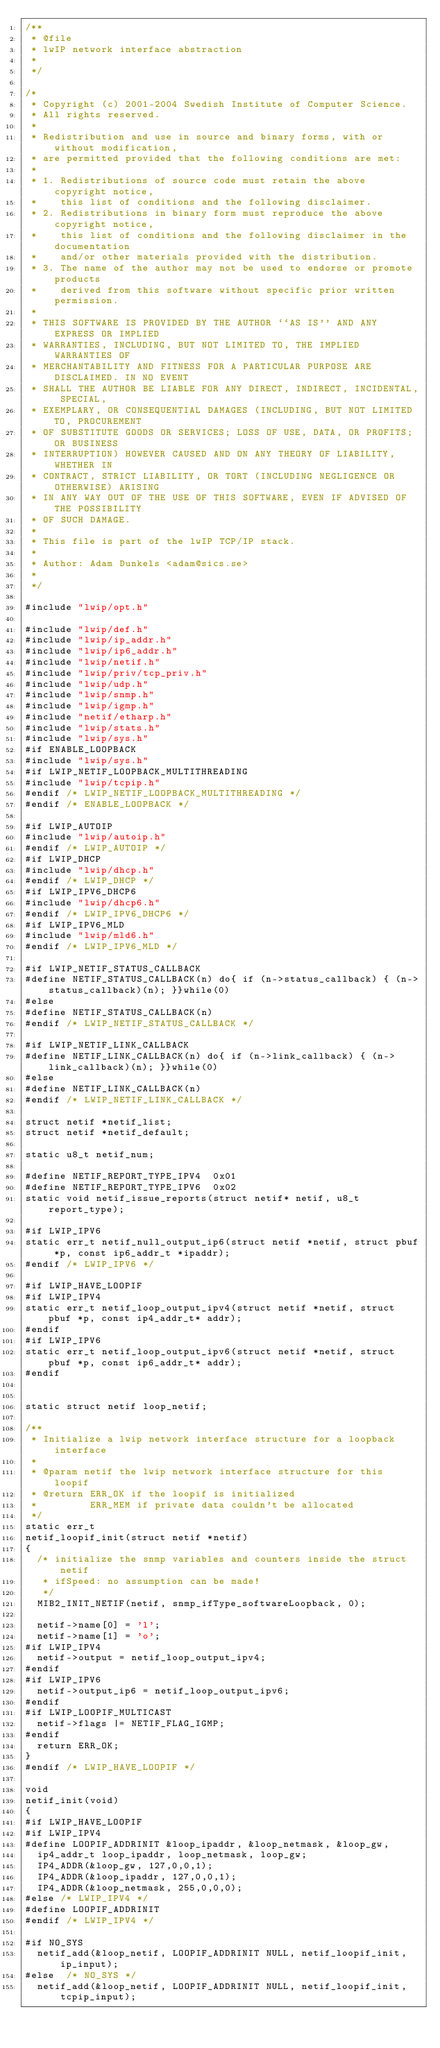<code> <loc_0><loc_0><loc_500><loc_500><_C_>/**
 * @file
 * lwIP network interface abstraction
 *
 */

/*
 * Copyright (c) 2001-2004 Swedish Institute of Computer Science.
 * All rights reserved.
 *
 * Redistribution and use in source and binary forms, with or without modification,
 * are permitted provided that the following conditions are met:
 *
 * 1. Redistributions of source code must retain the above copyright notice,
 *    this list of conditions and the following disclaimer.
 * 2. Redistributions in binary form must reproduce the above copyright notice,
 *    this list of conditions and the following disclaimer in the documentation
 *    and/or other materials provided with the distribution.
 * 3. The name of the author may not be used to endorse or promote products
 *    derived from this software without specific prior written permission.
 *
 * THIS SOFTWARE IS PROVIDED BY THE AUTHOR ``AS IS'' AND ANY EXPRESS OR IMPLIED
 * WARRANTIES, INCLUDING, BUT NOT LIMITED TO, THE IMPLIED WARRANTIES OF
 * MERCHANTABILITY AND FITNESS FOR A PARTICULAR PURPOSE ARE DISCLAIMED. IN NO EVENT
 * SHALL THE AUTHOR BE LIABLE FOR ANY DIRECT, INDIRECT, INCIDENTAL, SPECIAL,
 * EXEMPLARY, OR CONSEQUENTIAL DAMAGES (INCLUDING, BUT NOT LIMITED TO, PROCUREMENT
 * OF SUBSTITUTE GOODS OR SERVICES; LOSS OF USE, DATA, OR PROFITS; OR BUSINESS
 * INTERRUPTION) HOWEVER CAUSED AND ON ANY THEORY OF LIABILITY, WHETHER IN
 * CONTRACT, STRICT LIABILITY, OR TORT (INCLUDING NEGLIGENCE OR OTHERWISE) ARISING
 * IN ANY WAY OUT OF THE USE OF THIS SOFTWARE, EVEN IF ADVISED OF THE POSSIBILITY
 * OF SUCH DAMAGE.
 *
 * This file is part of the lwIP TCP/IP stack.
 *
 * Author: Adam Dunkels <adam@sics.se>
 *
 */

#include "lwip/opt.h"

#include "lwip/def.h"
#include "lwip/ip_addr.h"
#include "lwip/ip6_addr.h"
#include "lwip/netif.h"
#include "lwip/priv/tcp_priv.h"
#include "lwip/udp.h"
#include "lwip/snmp.h"
#include "lwip/igmp.h"
#include "netif/etharp.h"
#include "lwip/stats.h"
#include "lwip/sys.h"
#if ENABLE_LOOPBACK
#include "lwip/sys.h"
#if LWIP_NETIF_LOOPBACK_MULTITHREADING
#include "lwip/tcpip.h"
#endif /* LWIP_NETIF_LOOPBACK_MULTITHREADING */
#endif /* ENABLE_LOOPBACK */

#if LWIP_AUTOIP
#include "lwip/autoip.h"
#endif /* LWIP_AUTOIP */
#if LWIP_DHCP
#include "lwip/dhcp.h"
#endif /* LWIP_DHCP */
#if LWIP_IPV6_DHCP6
#include "lwip/dhcp6.h"
#endif /* LWIP_IPV6_DHCP6 */
#if LWIP_IPV6_MLD
#include "lwip/mld6.h"
#endif /* LWIP_IPV6_MLD */

#if LWIP_NETIF_STATUS_CALLBACK
#define NETIF_STATUS_CALLBACK(n) do{ if (n->status_callback) { (n->status_callback)(n); }}while(0)
#else
#define NETIF_STATUS_CALLBACK(n)
#endif /* LWIP_NETIF_STATUS_CALLBACK */

#if LWIP_NETIF_LINK_CALLBACK
#define NETIF_LINK_CALLBACK(n) do{ if (n->link_callback) { (n->link_callback)(n); }}while(0)
#else
#define NETIF_LINK_CALLBACK(n)
#endif /* LWIP_NETIF_LINK_CALLBACK */

struct netif *netif_list;
struct netif *netif_default;

static u8_t netif_num;

#define NETIF_REPORT_TYPE_IPV4  0x01
#define NETIF_REPORT_TYPE_IPV6  0x02
static void netif_issue_reports(struct netif* netif, u8_t report_type);

#if LWIP_IPV6
static err_t netif_null_output_ip6(struct netif *netif, struct pbuf *p, const ip6_addr_t *ipaddr);
#endif /* LWIP_IPV6 */

#if LWIP_HAVE_LOOPIF
#if LWIP_IPV4
static err_t netif_loop_output_ipv4(struct netif *netif, struct pbuf *p, const ip4_addr_t* addr);
#endif
#if LWIP_IPV6
static err_t netif_loop_output_ipv6(struct netif *netif, struct pbuf *p, const ip6_addr_t* addr);
#endif


static struct netif loop_netif;

/**
 * Initialize a lwip network interface structure for a loopback interface
 *
 * @param netif the lwip network interface structure for this loopif
 * @return ERR_OK if the loopif is initialized
 *         ERR_MEM if private data couldn't be allocated
 */
static err_t
netif_loopif_init(struct netif *netif)
{
  /* initialize the snmp variables and counters inside the struct netif
   * ifSpeed: no assumption can be made!
   */
  MIB2_INIT_NETIF(netif, snmp_ifType_softwareLoopback, 0);

  netif->name[0] = 'l';
  netif->name[1] = 'o';
#if LWIP_IPV4
  netif->output = netif_loop_output_ipv4;
#endif
#if LWIP_IPV6
  netif->output_ip6 = netif_loop_output_ipv6;
#endif
#if LWIP_LOOPIF_MULTICAST
  netif->flags |= NETIF_FLAG_IGMP;
#endif
  return ERR_OK;
}
#endif /* LWIP_HAVE_LOOPIF */

void
netif_init(void)
{
#if LWIP_HAVE_LOOPIF
#if LWIP_IPV4
#define LOOPIF_ADDRINIT &loop_ipaddr, &loop_netmask, &loop_gw,
  ip4_addr_t loop_ipaddr, loop_netmask, loop_gw;
  IP4_ADDR(&loop_gw, 127,0,0,1);
  IP4_ADDR(&loop_ipaddr, 127,0,0,1);
  IP4_ADDR(&loop_netmask, 255,0,0,0);
#else /* LWIP_IPV4 */
#define LOOPIF_ADDRINIT
#endif /* LWIP_IPV4 */

#if NO_SYS
  netif_add(&loop_netif, LOOPIF_ADDRINIT NULL, netif_loopif_init, ip_input);
#else  /* NO_SYS */
  netif_add(&loop_netif, LOOPIF_ADDRINIT NULL, netif_loopif_init, tcpip_input);</code> 